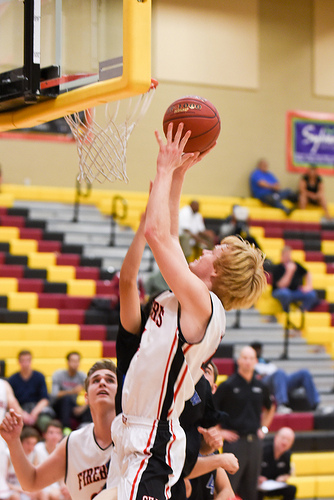<image>
Can you confirm if the basket is to the left of the ball? Yes. From this viewpoint, the basket is positioned to the left side relative to the ball. 